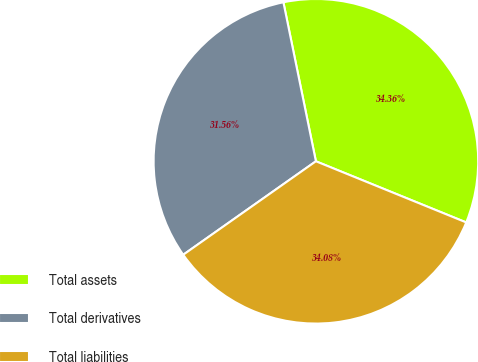<chart> <loc_0><loc_0><loc_500><loc_500><pie_chart><fcel>Total assets<fcel>Total derivatives<fcel>Total liabilities<nl><fcel>34.36%<fcel>31.56%<fcel>34.08%<nl></chart> 